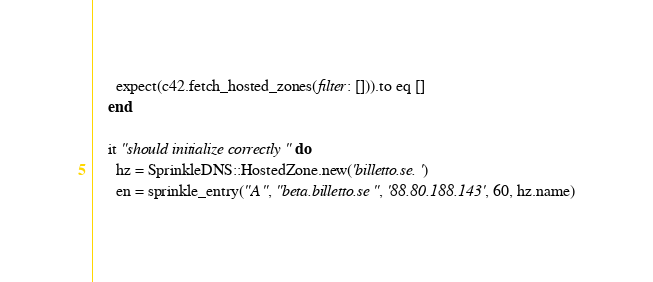<code> <loc_0><loc_0><loc_500><loc_500><_Ruby_>      expect(c42.fetch_hosted_zones(filter: [])).to eq []
    end

    it "should initialize correctly" do
      hz = SprinkleDNS::HostedZone.new('billetto.se.')
      en = sprinkle_entry("A", "beta.billetto.se", '88.80.188.143', 60, hz.name)</code> 